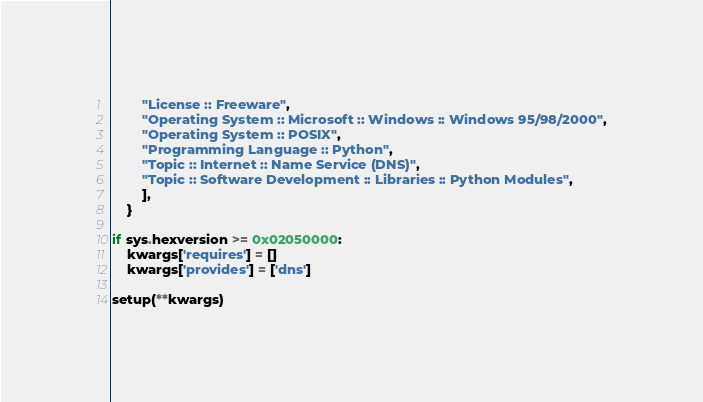Convert code to text. <code><loc_0><loc_0><loc_500><loc_500><_Python_>        "License :: Freeware",
        "Operating System :: Microsoft :: Windows :: Windows 95/98/2000",
        "Operating System :: POSIX",
        "Programming Language :: Python",
        "Topic :: Internet :: Name Service (DNS)",
        "Topic :: Software Development :: Libraries :: Python Modules",
        ],
    }

if sys.hexversion >= 0x02050000:
    kwargs['requires'] = []
    kwargs['provides'] = ['dns']

setup(**kwargs)
</code> 